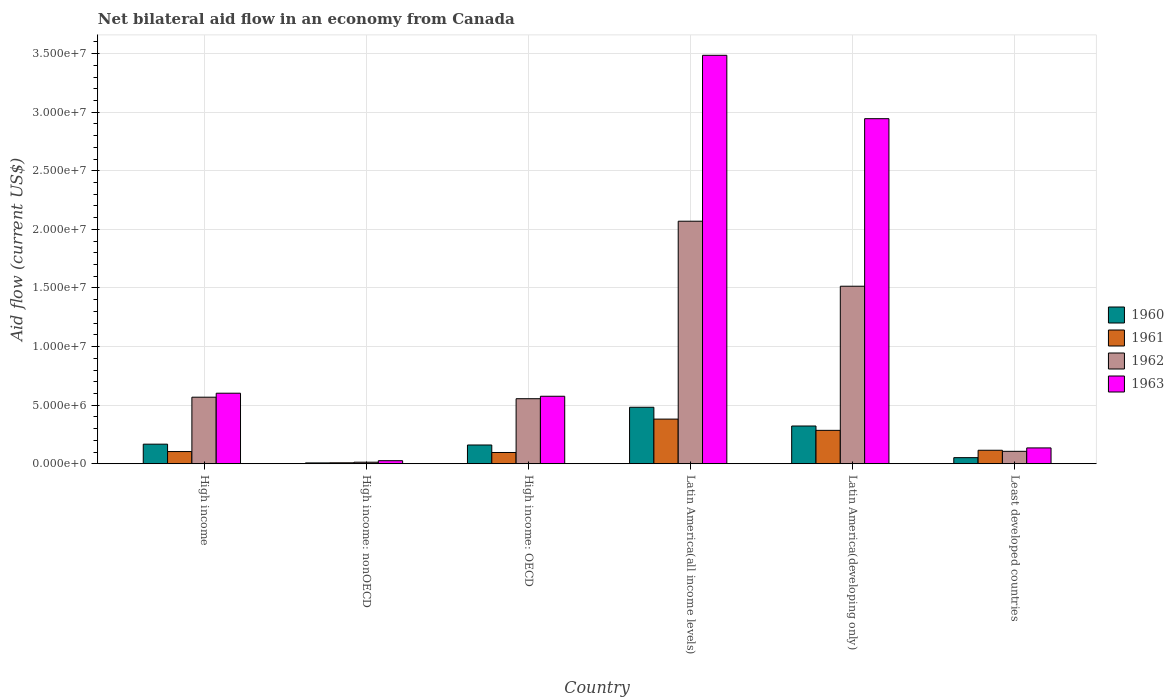How many groups of bars are there?
Keep it short and to the point. 6. Are the number of bars on each tick of the X-axis equal?
Keep it short and to the point. Yes. How many bars are there on the 1st tick from the left?
Provide a short and direct response. 4. How many bars are there on the 5th tick from the right?
Your response must be concise. 4. What is the label of the 2nd group of bars from the left?
Provide a succinct answer. High income: nonOECD. In how many cases, is the number of bars for a given country not equal to the number of legend labels?
Ensure brevity in your answer.  0. What is the net bilateral aid flow in 1961 in Latin America(all income levels)?
Keep it short and to the point. 3.81e+06. Across all countries, what is the maximum net bilateral aid flow in 1963?
Provide a succinct answer. 3.49e+07. Across all countries, what is the minimum net bilateral aid flow in 1960?
Provide a succinct answer. 7.00e+04. In which country was the net bilateral aid flow in 1962 maximum?
Your answer should be compact. Latin America(all income levels). In which country was the net bilateral aid flow in 1963 minimum?
Give a very brief answer. High income: nonOECD. What is the total net bilateral aid flow in 1963 in the graph?
Provide a succinct answer. 7.77e+07. What is the difference between the net bilateral aid flow in 1961 in High income and that in Latin America(developing only)?
Ensure brevity in your answer.  -1.81e+06. What is the difference between the net bilateral aid flow in 1960 in High income: nonOECD and the net bilateral aid flow in 1961 in Least developed countries?
Ensure brevity in your answer.  -1.08e+06. What is the average net bilateral aid flow in 1960 per country?
Offer a terse response. 1.98e+06. What is the difference between the net bilateral aid flow of/in 1962 and net bilateral aid flow of/in 1960 in Latin America(developing only)?
Your answer should be compact. 1.19e+07. In how many countries, is the net bilateral aid flow in 1960 greater than 17000000 US$?
Provide a succinct answer. 0. What is the ratio of the net bilateral aid flow in 1963 in High income: nonOECD to that in Latin America(developing only)?
Your answer should be compact. 0.01. Is the net bilateral aid flow in 1962 in High income: OECD less than that in Latin America(developing only)?
Give a very brief answer. Yes. What is the difference between the highest and the second highest net bilateral aid flow in 1960?
Ensure brevity in your answer.  1.60e+06. What is the difference between the highest and the lowest net bilateral aid flow in 1960?
Your answer should be compact. 4.75e+06. In how many countries, is the net bilateral aid flow in 1962 greater than the average net bilateral aid flow in 1962 taken over all countries?
Make the answer very short. 2. Is the sum of the net bilateral aid flow in 1963 in Latin America(developing only) and Least developed countries greater than the maximum net bilateral aid flow in 1960 across all countries?
Make the answer very short. Yes. Is it the case that in every country, the sum of the net bilateral aid flow in 1960 and net bilateral aid flow in 1963 is greater than the sum of net bilateral aid flow in 1961 and net bilateral aid flow in 1962?
Your answer should be very brief. No. What does the 1st bar from the left in High income: nonOECD represents?
Offer a very short reply. 1960. Is it the case that in every country, the sum of the net bilateral aid flow in 1961 and net bilateral aid flow in 1962 is greater than the net bilateral aid flow in 1963?
Offer a terse response. No. How many bars are there?
Your answer should be very brief. 24. Are all the bars in the graph horizontal?
Give a very brief answer. No. How many countries are there in the graph?
Make the answer very short. 6. How many legend labels are there?
Make the answer very short. 4. How are the legend labels stacked?
Your answer should be very brief. Vertical. What is the title of the graph?
Make the answer very short. Net bilateral aid flow in an economy from Canada. Does "1974" appear as one of the legend labels in the graph?
Provide a short and direct response. No. What is the label or title of the Y-axis?
Provide a short and direct response. Aid flow (current US$). What is the Aid flow (current US$) in 1960 in High income?
Provide a succinct answer. 1.67e+06. What is the Aid flow (current US$) in 1961 in High income?
Ensure brevity in your answer.  1.04e+06. What is the Aid flow (current US$) of 1962 in High income?
Offer a terse response. 5.68e+06. What is the Aid flow (current US$) in 1963 in High income?
Provide a succinct answer. 6.02e+06. What is the Aid flow (current US$) of 1960 in High income: nonOECD?
Offer a terse response. 7.00e+04. What is the Aid flow (current US$) in 1960 in High income: OECD?
Offer a terse response. 1.60e+06. What is the Aid flow (current US$) of 1961 in High income: OECD?
Make the answer very short. 9.60e+05. What is the Aid flow (current US$) of 1962 in High income: OECD?
Your answer should be compact. 5.55e+06. What is the Aid flow (current US$) of 1963 in High income: OECD?
Offer a terse response. 5.76e+06. What is the Aid flow (current US$) in 1960 in Latin America(all income levels)?
Make the answer very short. 4.82e+06. What is the Aid flow (current US$) of 1961 in Latin America(all income levels)?
Ensure brevity in your answer.  3.81e+06. What is the Aid flow (current US$) in 1962 in Latin America(all income levels)?
Ensure brevity in your answer.  2.07e+07. What is the Aid flow (current US$) of 1963 in Latin America(all income levels)?
Keep it short and to the point. 3.49e+07. What is the Aid flow (current US$) of 1960 in Latin America(developing only)?
Your answer should be compact. 3.22e+06. What is the Aid flow (current US$) in 1961 in Latin America(developing only)?
Ensure brevity in your answer.  2.85e+06. What is the Aid flow (current US$) of 1962 in Latin America(developing only)?
Offer a terse response. 1.52e+07. What is the Aid flow (current US$) of 1963 in Latin America(developing only)?
Give a very brief answer. 2.94e+07. What is the Aid flow (current US$) in 1960 in Least developed countries?
Provide a succinct answer. 5.20e+05. What is the Aid flow (current US$) in 1961 in Least developed countries?
Your answer should be compact. 1.15e+06. What is the Aid flow (current US$) in 1962 in Least developed countries?
Give a very brief answer. 1.06e+06. What is the Aid flow (current US$) in 1963 in Least developed countries?
Keep it short and to the point. 1.35e+06. Across all countries, what is the maximum Aid flow (current US$) in 1960?
Your answer should be very brief. 4.82e+06. Across all countries, what is the maximum Aid flow (current US$) in 1961?
Your response must be concise. 3.81e+06. Across all countries, what is the maximum Aid flow (current US$) of 1962?
Offer a terse response. 2.07e+07. Across all countries, what is the maximum Aid flow (current US$) of 1963?
Ensure brevity in your answer.  3.49e+07. Across all countries, what is the minimum Aid flow (current US$) of 1962?
Your answer should be very brief. 1.30e+05. Across all countries, what is the minimum Aid flow (current US$) in 1963?
Your answer should be compact. 2.60e+05. What is the total Aid flow (current US$) of 1960 in the graph?
Your answer should be very brief. 1.19e+07. What is the total Aid flow (current US$) in 1961 in the graph?
Make the answer very short. 9.89e+06. What is the total Aid flow (current US$) of 1962 in the graph?
Keep it short and to the point. 4.83e+07. What is the total Aid flow (current US$) of 1963 in the graph?
Offer a terse response. 7.77e+07. What is the difference between the Aid flow (current US$) of 1960 in High income and that in High income: nonOECD?
Ensure brevity in your answer.  1.60e+06. What is the difference between the Aid flow (current US$) of 1961 in High income and that in High income: nonOECD?
Keep it short and to the point. 9.60e+05. What is the difference between the Aid flow (current US$) of 1962 in High income and that in High income: nonOECD?
Your response must be concise. 5.55e+06. What is the difference between the Aid flow (current US$) in 1963 in High income and that in High income: nonOECD?
Your answer should be compact. 5.76e+06. What is the difference between the Aid flow (current US$) of 1960 in High income and that in High income: OECD?
Keep it short and to the point. 7.00e+04. What is the difference between the Aid flow (current US$) of 1960 in High income and that in Latin America(all income levels)?
Your response must be concise. -3.15e+06. What is the difference between the Aid flow (current US$) in 1961 in High income and that in Latin America(all income levels)?
Your answer should be compact. -2.77e+06. What is the difference between the Aid flow (current US$) of 1962 in High income and that in Latin America(all income levels)?
Your answer should be very brief. -1.50e+07. What is the difference between the Aid flow (current US$) in 1963 in High income and that in Latin America(all income levels)?
Give a very brief answer. -2.88e+07. What is the difference between the Aid flow (current US$) of 1960 in High income and that in Latin America(developing only)?
Offer a very short reply. -1.55e+06. What is the difference between the Aid flow (current US$) in 1961 in High income and that in Latin America(developing only)?
Give a very brief answer. -1.81e+06. What is the difference between the Aid flow (current US$) in 1962 in High income and that in Latin America(developing only)?
Provide a succinct answer. -9.47e+06. What is the difference between the Aid flow (current US$) of 1963 in High income and that in Latin America(developing only)?
Provide a succinct answer. -2.34e+07. What is the difference between the Aid flow (current US$) of 1960 in High income and that in Least developed countries?
Ensure brevity in your answer.  1.15e+06. What is the difference between the Aid flow (current US$) in 1962 in High income and that in Least developed countries?
Your answer should be very brief. 4.62e+06. What is the difference between the Aid flow (current US$) of 1963 in High income and that in Least developed countries?
Your answer should be compact. 4.67e+06. What is the difference between the Aid flow (current US$) in 1960 in High income: nonOECD and that in High income: OECD?
Make the answer very short. -1.53e+06. What is the difference between the Aid flow (current US$) in 1961 in High income: nonOECD and that in High income: OECD?
Your response must be concise. -8.80e+05. What is the difference between the Aid flow (current US$) of 1962 in High income: nonOECD and that in High income: OECD?
Keep it short and to the point. -5.42e+06. What is the difference between the Aid flow (current US$) in 1963 in High income: nonOECD and that in High income: OECD?
Keep it short and to the point. -5.50e+06. What is the difference between the Aid flow (current US$) in 1960 in High income: nonOECD and that in Latin America(all income levels)?
Keep it short and to the point. -4.75e+06. What is the difference between the Aid flow (current US$) in 1961 in High income: nonOECD and that in Latin America(all income levels)?
Ensure brevity in your answer.  -3.73e+06. What is the difference between the Aid flow (current US$) in 1962 in High income: nonOECD and that in Latin America(all income levels)?
Keep it short and to the point. -2.06e+07. What is the difference between the Aid flow (current US$) of 1963 in High income: nonOECD and that in Latin America(all income levels)?
Your answer should be very brief. -3.46e+07. What is the difference between the Aid flow (current US$) of 1960 in High income: nonOECD and that in Latin America(developing only)?
Your answer should be very brief. -3.15e+06. What is the difference between the Aid flow (current US$) of 1961 in High income: nonOECD and that in Latin America(developing only)?
Your answer should be very brief. -2.77e+06. What is the difference between the Aid flow (current US$) in 1962 in High income: nonOECD and that in Latin America(developing only)?
Give a very brief answer. -1.50e+07. What is the difference between the Aid flow (current US$) in 1963 in High income: nonOECD and that in Latin America(developing only)?
Keep it short and to the point. -2.92e+07. What is the difference between the Aid flow (current US$) in 1960 in High income: nonOECD and that in Least developed countries?
Your answer should be very brief. -4.50e+05. What is the difference between the Aid flow (current US$) of 1961 in High income: nonOECD and that in Least developed countries?
Your response must be concise. -1.07e+06. What is the difference between the Aid flow (current US$) of 1962 in High income: nonOECD and that in Least developed countries?
Make the answer very short. -9.30e+05. What is the difference between the Aid flow (current US$) of 1963 in High income: nonOECD and that in Least developed countries?
Your response must be concise. -1.09e+06. What is the difference between the Aid flow (current US$) in 1960 in High income: OECD and that in Latin America(all income levels)?
Your answer should be compact. -3.22e+06. What is the difference between the Aid flow (current US$) in 1961 in High income: OECD and that in Latin America(all income levels)?
Offer a very short reply. -2.85e+06. What is the difference between the Aid flow (current US$) in 1962 in High income: OECD and that in Latin America(all income levels)?
Give a very brief answer. -1.52e+07. What is the difference between the Aid flow (current US$) in 1963 in High income: OECD and that in Latin America(all income levels)?
Offer a terse response. -2.91e+07. What is the difference between the Aid flow (current US$) in 1960 in High income: OECD and that in Latin America(developing only)?
Your response must be concise. -1.62e+06. What is the difference between the Aid flow (current US$) in 1961 in High income: OECD and that in Latin America(developing only)?
Offer a very short reply. -1.89e+06. What is the difference between the Aid flow (current US$) of 1962 in High income: OECD and that in Latin America(developing only)?
Offer a terse response. -9.60e+06. What is the difference between the Aid flow (current US$) in 1963 in High income: OECD and that in Latin America(developing only)?
Provide a succinct answer. -2.37e+07. What is the difference between the Aid flow (current US$) in 1960 in High income: OECD and that in Least developed countries?
Your answer should be very brief. 1.08e+06. What is the difference between the Aid flow (current US$) in 1961 in High income: OECD and that in Least developed countries?
Make the answer very short. -1.90e+05. What is the difference between the Aid flow (current US$) in 1962 in High income: OECD and that in Least developed countries?
Offer a very short reply. 4.49e+06. What is the difference between the Aid flow (current US$) of 1963 in High income: OECD and that in Least developed countries?
Offer a terse response. 4.41e+06. What is the difference between the Aid flow (current US$) in 1960 in Latin America(all income levels) and that in Latin America(developing only)?
Your answer should be compact. 1.60e+06. What is the difference between the Aid flow (current US$) of 1961 in Latin America(all income levels) and that in Latin America(developing only)?
Ensure brevity in your answer.  9.60e+05. What is the difference between the Aid flow (current US$) of 1962 in Latin America(all income levels) and that in Latin America(developing only)?
Your response must be concise. 5.55e+06. What is the difference between the Aid flow (current US$) of 1963 in Latin America(all income levels) and that in Latin America(developing only)?
Provide a succinct answer. 5.41e+06. What is the difference between the Aid flow (current US$) of 1960 in Latin America(all income levels) and that in Least developed countries?
Your answer should be compact. 4.30e+06. What is the difference between the Aid flow (current US$) of 1961 in Latin America(all income levels) and that in Least developed countries?
Offer a very short reply. 2.66e+06. What is the difference between the Aid flow (current US$) of 1962 in Latin America(all income levels) and that in Least developed countries?
Provide a succinct answer. 1.96e+07. What is the difference between the Aid flow (current US$) in 1963 in Latin America(all income levels) and that in Least developed countries?
Ensure brevity in your answer.  3.35e+07. What is the difference between the Aid flow (current US$) in 1960 in Latin America(developing only) and that in Least developed countries?
Your answer should be compact. 2.70e+06. What is the difference between the Aid flow (current US$) of 1961 in Latin America(developing only) and that in Least developed countries?
Provide a succinct answer. 1.70e+06. What is the difference between the Aid flow (current US$) of 1962 in Latin America(developing only) and that in Least developed countries?
Your answer should be very brief. 1.41e+07. What is the difference between the Aid flow (current US$) in 1963 in Latin America(developing only) and that in Least developed countries?
Provide a short and direct response. 2.81e+07. What is the difference between the Aid flow (current US$) in 1960 in High income and the Aid flow (current US$) in 1961 in High income: nonOECD?
Keep it short and to the point. 1.59e+06. What is the difference between the Aid flow (current US$) of 1960 in High income and the Aid flow (current US$) of 1962 in High income: nonOECD?
Give a very brief answer. 1.54e+06. What is the difference between the Aid flow (current US$) in 1960 in High income and the Aid flow (current US$) in 1963 in High income: nonOECD?
Give a very brief answer. 1.41e+06. What is the difference between the Aid flow (current US$) in 1961 in High income and the Aid flow (current US$) in 1962 in High income: nonOECD?
Make the answer very short. 9.10e+05. What is the difference between the Aid flow (current US$) in 1961 in High income and the Aid flow (current US$) in 1963 in High income: nonOECD?
Provide a succinct answer. 7.80e+05. What is the difference between the Aid flow (current US$) of 1962 in High income and the Aid flow (current US$) of 1963 in High income: nonOECD?
Provide a short and direct response. 5.42e+06. What is the difference between the Aid flow (current US$) of 1960 in High income and the Aid flow (current US$) of 1961 in High income: OECD?
Your answer should be compact. 7.10e+05. What is the difference between the Aid flow (current US$) in 1960 in High income and the Aid flow (current US$) in 1962 in High income: OECD?
Provide a succinct answer. -3.88e+06. What is the difference between the Aid flow (current US$) in 1960 in High income and the Aid flow (current US$) in 1963 in High income: OECD?
Offer a very short reply. -4.09e+06. What is the difference between the Aid flow (current US$) in 1961 in High income and the Aid flow (current US$) in 1962 in High income: OECD?
Offer a terse response. -4.51e+06. What is the difference between the Aid flow (current US$) of 1961 in High income and the Aid flow (current US$) of 1963 in High income: OECD?
Give a very brief answer. -4.72e+06. What is the difference between the Aid flow (current US$) in 1960 in High income and the Aid flow (current US$) in 1961 in Latin America(all income levels)?
Keep it short and to the point. -2.14e+06. What is the difference between the Aid flow (current US$) of 1960 in High income and the Aid flow (current US$) of 1962 in Latin America(all income levels)?
Provide a succinct answer. -1.90e+07. What is the difference between the Aid flow (current US$) in 1960 in High income and the Aid flow (current US$) in 1963 in Latin America(all income levels)?
Provide a short and direct response. -3.32e+07. What is the difference between the Aid flow (current US$) of 1961 in High income and the Aid flow (current US$) of 1962 in Latin America(all income levels)?
Keep it short and to the point. -1.97e+07. What is the difference between the Aid flow (current US$) in 1961 in High income and the Aid flow (current US$) in 1963 in Latin America(all income levels)?
Provide a succinct answer. -3.38e+07. What is the difference between the Aid flow (current US$) of 1962 in High income and the Aid flow (current US$) of 1963 in Latin America(all income levels)?
Provide a short and direct response. -2.92e+07. What is the difference between the Aid flow (current US$) in 1960 in High income and the Aid flow (current US$) in 1961 in Latin America(developing only)?
Your response must be concise. -1.18e+06. What is the difference between the Aid flow (current US$) in 1960 in High income and the Aid flow (current US$) in 1962 in Latin America(developing only)?
Offer a very short reply. -1.35e+07. What is the difference between the Aid flow (current US$) in 1960 in High income and the Aid flow (current US$) in 1963 in Latin America(developing only)?
Make the answer very short. -2.78e+07. What is the difference between the Aid flow (current US$) of 1961 in High income and the Aid flow (current US$) of 1962 in Latin America(developing only)?
Make the answer very short. -1.41e+07. What is the difference between the Aid flow (current US$) in 1961 in High income and the Aid flow (current US$) in 1963 in Latin America(developing only)?
Your answer should be compact. -2.84e+07. What is the difference between the Aid flow (current US$) in 1962 in High income and the Aid flow (current US$) in 1963 in Latin America(developing only)?
Your answer should be very brief. -2.38e+07. What is the difference between the Aid flow (current US$) in 1960 in High income and the Aid flow (current US$) in 1961 in Least developed countries?
Your response must be concise. 5.20e+05. What is the difference between the Aid flow (current US$) of 1960 in High income and the Aid flow (current US$) of 1963 in Least developed countries?
Provide a short and direct response. 3.20e+05. What is the difference between the Aid flow (current US$) of 1961 in High income and the Aid flow (current US$) of 1962 in Least developed countries?
Your answer should be very brief. -2.00e+04. What is the difference between the Aid flow (current US$) in 1961 in High income and the Aid flow (current US$) in 1963 in Least developed countries?
Your response must be concise. -3.10e+05. What is the difference between the Aid flow (current US$) in 1962 in High income and the Aid flow (current US$) in 1963 in Least developed countries?
Your response must be concise. 4.33e+06. What is the difference between the Aid flow (current US$) of 1960 in High income: nonOECD and the Aid flow (current US$) of 1961 in High income: OECD?
Ensure brevity in your answer.  -8.90e+05. What is the difference between the Aid flow (current US$) of 1960 in High income: nonOECD and the Aid flow (current US$) of 1962 in High income: OECD?
Keep it short and to the point. -5.48e+06. What is the difference between the Aid flow (current US$) of 1960 in High income: nonOECD and the Aid flow (current US$) of 1963 in High income: OECD?
Keep it short and to the point. -5.69e+06. What is the difference between the Aid flow (current US$) in 1961 in High income: nonOECD and the Aid flow (current US$) in 1962 in High income: OECD?
Make the answer very short. -5.47e+06. What is the difference between the Aid flow (current US$) in 1961 in High income: nonOECD and the Aid flow (current US$) in 1963 in High income: OECD?
Give a very brief answer. -5.68e+06. What is the difference between the Aid flow (current US$) in 1962 in High income: nonOECD and the Aid flow (current US$) in 1963 in High income: OECD?
Provide a succinct answer. -5.63e+06. What is the difference between the Aid flow (current US$) in 1960 in High income: nonOECD and the Aid flow (current US$) in 1961 in Latin America(all income levels)?
Make the answer very short. -3.74e+06. What is the difference between the Aid flow (current US$) of 1960 in High income: nonOECD and the Aid flow (current US$) of 1962 in Latin America(all income levels)?
Provide a short and direct response. -2.06e+07. What is the difference between the Aid flow (current US$) in 1960 in High income: nonOECD and the Aid flow (current US$) in 1963 in Latin America(all income levels)?
Ensure brevity in your answer.  -3.48e+07. What is the difference between the Aid flow (current US$) of 1961 in High income: nonOECD and the Aid flow (current US$) of 1962 in Latin America(all income levels)?
Ensure brevity in your answer.  -2.06e+07. What is the difference between the Aid flow (current US$) of 1961 in High income: nonOECD and the Aid flow (current US$) of 1963 in Latin America(all income levels)?
Make the answer very short. -3.48e+07. What is the difference between the Aid flow (current US$) of 1962 in High income: nonOECD and the Aid flow (current US$) of 1963 in Latin America(all income levels)?
Provide a short and direct response. -3.47e+07. What is the difference between the Aid flow (current US$) of 1960 in High income: nonOECD and the Aid flow (current US$) of 1961 in Latin America(developing only)?
Make the answer very short. -2.78e+06. What is the difference between the Aid flow (current US$) in 1960 in High income: nonOECD and the Aid flow (current US$) in 1962 in Latin America(developing only)?
Your answer should be very brief. -1.51e+07. What is the difference between the Aid flow (current US$) in 1960 in High income: nonOECD and the Aid flow (current US$) in 1963 in Latin America(developing only)?
Keep it short and to the point. -2.94e+07. What is the difference between the Aid flow (current US$) of 1961 in High income: nonOECD and the Aid flow (current US$) of 1962 in Latin America(developing only)?
Make the answer very short. -1.51e+07. What is the difference between the Aid flow (current US$) of 1961 in High income: nonOECD and the Aid flow (current US$) of 1963 in Latin America(developing only)?
Offer a very short reply. -2.94e+07. What is the difference between the Aid flow (current US$) of 1962 in High income: nonOECD and the Aid flow (current US$) of 1963 in Latin America(developing only)?
Your response must be concise. -2.93e+07. What is the difference between the Aid flow (current US$) in 1960 in High income: nonOECD and the Aid flow (current US$) in 1961 in Least developed countries?
Provide a short and direct response. -1.08e+06. What is the difference between the Aid flow (current US$) in 1960 in High income: nonOECD and the Aid flow (current US$) in 1962 in Least developed countries?
Your response must be concise. -9.90e+05. What is the difference between the Aid flow (current US$) in 1960 in High income: nonOECD and the Aid flow (current US$) in 1963 in Least developed countries?
Give a very brief answer. -1.28e+06. What is the difference between the Aid flow (current US$) of 1961 in High income: nonOECD and the Aid flow (current US$) of 1962 in Least developed countries?
Provide a succinct answer. -9.80e+05. What is the difference between the Aid flow (current US$) of 1961 in High income: nonOECD and the Aid flow (current US$) of 1963 in Least developed countries?
Provide a succinct answer. -1.27e+06. What is the difference between the Aid flow (current US$) of 1962 in High income: nonOECD and the Aid flow (current US$) of 1963 in Least developed countries?
Make the answer very short. -1.22e+06. What is the difference between the Aid flow (current US$) of 1960 in High income: OECD and the Aid flow (current US$) of 1961 in Latin America(all income levels)?
Offer a terse response. -2.21e+06. What is the difference between the Aid flow (current US$) of 1960 in High income: OECD and the Aid flow (current US$) of 1962 in Latin America(all income levels)?
Provide a succinct answer. -1.91e+07. What is the difference between the Aid flow (current US$) in 1960 in High income: OECD and the Aid flow (current US$) in 1963 in Latin America(all income levels)?
Offer a very short reply. -3.33e+07. What is the difference between the Aid flow (current US$) in 1961 in High income: OECD and the Aid flow (current US$) in 1962 in Latin America(all income levels)?
Keep it short and to the point. -1.97e+07. What is the difference between the Aid flow (current US$) in 1961 in High income: OECD and the Aid flow (current US$) in 1963 in Latin America(all income levels)?
Your answer should be very brief. -3.39e+07. What is the difference between the Aid flow (current US$) of 1962 in High income: OECD and the Aid flow (current US$) of 1963 in Latin America(all income levels)?
Your answer should be very brief. -2.93e+07. What is the difference between the Aid flow (current US$) in 1960 in High income: OECD and the Aid flow (current US$) in 1961 in Latin America(developing only)?
Your response must be concise. -1.25e+06. What is the difference between the Aid flow (current US$) in 1960 in High income: OECD and the Aid flow (current US$) in 1962 in Latin America(developing only)?
Provide a succinct answer. -1.36e+07. What is the difference between the Aid flow (current US$) of 1960 in High income: OECD and the Aid flow (current US$) of 1963 in Latin America(developing only)?
Your answer should be very brief. -2.78e+07. What is the difference between the Aid flow (current US$) of 1961 in High income: OECD and the Aid flow (current US$) of 1962 in Latin America(developing only)?
Provide a short and direct response. -1.42e+07. What is the difference between the Aid flow (current US$) of 1961 in High income: OECD and the Aid flow (current US$) of 1963 in Latin America(developing only)?
Offer a terse response. -2.85e+07. What is the difference between the Aid flow (current US$) of 1962 in High income: OECD and the Aid flow (current US$) of 1963 in Latin America(developing only)?
Keep it short and to the point. -2.39e+07. What is the difference between the Aid flow (current US$) of 1960 in High income: OECD and the Aid flow (current US$) of 1962 in Least developed countries?
Make the answer very short. 5.40e+05. What is the difference between the Aid flow (current US$) in 1960 in High income: OECD and the Aid flow (current US$) in 1963 in Least developed countries?
Provide a succinct answer. 2.50e+05. What is the difference between the Aid flow (current US$) of 1961 in High income: OECD and the Aid flow (current US$) of 1962 in Least developed countries?
Provide a succinct answer. -1.00e+05. What is the difference between the Aid flow (current US$) of 1961 in High income: OECD and the Aid flow (current US$) of 1963 in Least developed countries?
Make the answer very short. -3.90e+05. What is the difference between the Aid flow (current US$) in 1962 in High income: OECD and the Aid flow (current US$) in 1963 in Least developed countries?
Provide a short and direct response. 4.20e+06. What is the difference between the Aid flow (current US$) in 1960 in Latin America(all income levels) and the Aid flow (current US$) in 1961 in Latin America(developing only)?
Your answer should be very brief. 1.97e+06. What is the difference between the Aid flow (current US$) of 1960 in Latin America(all income levels) and the Aid flow (current US$) of 1962 in Latin America(developing only)?
Provide a succinct answer. -1.03e+07. What is the difference between the Aid flow (current US$) of 1960 in Latin America(all income levels) and the Aid flow (current US$) of 1963 in Latin America(developing only)?
Ensure brevity in your answer.  -2.46e+07. What is the difference between the Aid flow (current US$) in 1961 in Latin America(all income levels) and the Aid flow (current US$) in 1962 in Latin America(developing only)?
Give a very brief answer. -1.13e+07. What is the difference between the Aid flow (current US$) of 1961 in Latin America(all income levels) and the Aid flow (current US$) of 1963 in Latin America(developing only)?
Keep it short and to the point. -2.56e+07. What is the difference between the Aid flow (current US$) in 1962 in Latin America(all income levels) and the Aid flow (current US$) in 1963 in Latin America(developing only)?
Your answer should be very brief. -8.75e+06. What is the difference between the Aid flow (current US$) in 1960 in Latin America(all income levels) and the Aid flow (current US$) in 1961 in Least developed countries?
Your response must be concise. 3.67e+06. What is the difference between the Aid flow (current US$) of 1960 in Latin America(all income levels) and the Aid flow (current US$) of 1962 in Least developed countries?
Provide a succinct answer. 3.76e+06. What is the difference between the Aid flow (current US$) of 1960 in Latin America(all income levels) and the Aid flow (current US$) of 1963 in Least developed countries?
Your answer should be compact. 3.47e+06. What is the difference between the Aid flow (current US$) in 1961 in Latin America(all income levels) and the Aid flow (current US$) in 1962 in Least developed countries?
Make the answer very short. 2.75e+06. What is the difference between the Aid flow (current US$) in 1961 in Latin America(all income levels) and the Aid flow (current US$) in 1963 in Least developed countries?
Ensure brevity in your answer.  2.46e+06. What is the difference between the Aid flow (current US$) in 1962 in Latin America(all income levels) and the Aid flow (current US$) in 1963 in Least developed countries?
Make the answer very short. 1.94e+07. What is the difference between the Aid flow (current US$) in 1960 in Latin America(developing only) and the Aid flow (current US$) in 1961 in Least developed countries?
Your response must be concise. 2.07e+06. What is the difference between the Aid flow (current US$) of 1960 in Latin America(developing only) and the Aid flow (current US$) of 1962 in Least developed countries?
Offer a very short reply. 2.16e+06. What is the difference between the Aid flow (current US$) of 1960 in Latin America(developing only) and the Aid flow (current US$) of 1963 in Least developed countries?
Provide a succinct answer. 1.87e+06. What is the difference between the Aid flow (current US$) in 1961 in Latin America(developing only) and the Aid flow (current US$) in 1962 in Least developed countries?
Your answer should be compact. 1.79e+06. What is the difference between the Aid flow (current US$) of 1961 in Latin America(developing only) and the Aid flow (current US$) of 1963 in Least developed countries?
Offer a terse response. 1.50e+06. What is the difference between the Aid flow (current US$) of 1962 in Latin America(developing only) and the Aid flow (current US$) of 1963 in Least developed countries?
Provide a succinct answer. 1.38e+07. What is the average Aid flow (current US$) in 1960 per country?
Give a very brief answer. 1.98e+06. What is the average Aid flow (current US$) of 1961 per country?
Your response must be concise. 1.65e+06. What is the average Aid flow (current US$) in 1962 per country?
Keep it short and to the point. 8.04e+06. What is the average Aid flow (current US$) of 1963 per country?
Offer a very short reply. 1.30e+07. What is the difference between the Aid flow (current US$) in 1960 and Aid flow (current US$) in 1961 in High income?
Ensure brevity in your answer.  6.30e+05. What is the difference between the Aid flow (current US$) in 1960 and Aid flow (current US$) in 1962 in High income?
Provide a succinct answer. -4.01e+06. What is the difference between the Aid flow (current US$) of 1960 and Aid flow (current US$) of 1963 in High income?
Your response must be concise. -4.35e+06. What is the difference between the Aid flow (current US$) in 1961 and Aid flow (current US$) in 1962 in High income?
Make the answer very short. -4.64e+06. What is the difference between the Aid flow (current US$) in 1961 and Aid flow (current US$) in 1963 in High income?
Keep it short and to the point. -4.98e+06. What is the difference between the Aid flow (current US$) of 1960 and Aid flow (current US$) of 1961 in High income: nonOECD?
Provide a succinct answer. -10000. What is the difference between the Aid flow (current US$) of 1960 and Aid flow (current US$) of 1963 in High income: nonOECD?
Offer a terse response. -1.90e+05. What is the difference between the Aid flow (current US$) of 1961 and Aid flow (current US$) of 1962 in High income: nonOECD?
Offer a terse response. -5.00e+04. What is the difference between the Aid flow (current US$) of 1961 and Aid flow (current US$) of 1963 in High income: nonOECD?
Offer a very short reply. -1.80e+05. What is the difference between the Aid flow (current US$) of 1960 and Aid flow (current US$) of 1961 in High income: OECD?
Your response must be concise. 6.40e+05. What is the difference between the Aid flow (current US$) of 1960 and Aid flow (current US$) of 1962 in High income: OECD?
Offer a very short reply. -3.95e+06. What is the difference between the Aid flow (current US$) of 1960 and Aid flow (current US$) of 1963 in High income: OECD?
Give a very brief answer. -4.16e+06. What is the difference between the Aid flow (current US$) in 1961 and Aid flow (current US$) in 1962 in High income: OECD?
Make the answer very short. -4.59e+06. What is the difference between the Aid flow (current US$) of 1961 and Aid flow (current US$) of 1963 in High income: OECD?
Provide a succinct answer. -4.80e+06. What is the difference between the Aid flow (current US$) of 1962 and Aid flow (current US$) of 1963 in High income: OECD?
Give a very brief answer. -2.10e+05. What is the difference between the Aid flow (current US$) of 1960 and Aid flow (current US$) of 1961 in Latin America(all income levels)?
Provide a succinct answer. 1.01e+06. What is the difference between the Aid flow (current US$) of 1960 and Aid flow (current US$) of 1962 in Latin America(all income levels)?
Offer a very short reply. -1.59e+07. What is the difference between the Aid flow (current US$) of 1960 and Aid flow (current US$) of 1963 in Latin America(all income levels)?
Provide a succinct answer. -3.00e+07. What is the difference between the Aid flow (current US$) in 1961 and Aid flow (current US$) in 1962 in Latin America(all income levels)?
Your answer should be very brief. -1.69e+07. What is the difference between the Aid flow (current US$) in 1961 and Aid flow (current US$) in 1963 in Latin America(all income levels)?
Your response must be concise. -3.10e+07. What is the difference between the Aid flow (current US$) of 1962 and Aid flow (current US$) of 1963 in Latin America(all income levels)?
Keep it short and to the point. -1.42e+07. What is the difference between the Aid flow (current US$) of 1960 and Aid flow (current US$) of 1962 in Latin America(developing only)?
Your answer should be compact. -1.19e+07. What is the difference between the Aid flow (current US$) of 1960 and Aid flow (current US$) of 1963 in Latin America(developing only)?
Provide a succinct answer. -2.62e+07. What is the difference between the Aid flow (current US$) in 1961 and Aid flow (current US$) in 1962 in Latin America(developing only)?
Offer a terse response. -1.23e+07. What is the difference between the Aid flow (current US$) in 1961 and Aid flow (current US$) in 1963 in Latin America(developing only)?
Provide a short and direct response. -2.66e+07. What is the difference between the Aid flow (current US$) in 1962 and Aid flow (current US$) in 1963 in Latin America(developing only)?
Provide a succinct answer. -1.43e+07. What is the difference between the Aid flow (current US$) of 1960 and Aid flow (current US$) of 1961 in Least developed countries?
Your answer should be very brief. -6.30e+05. What is the difference between the Aid flow (current US$) in 1960 and Aid flow (current US$) in 1962 in Least developed countries?
Keep it short and to the point. -5.40e+05. What is the difference between the Aid flow (current US$) of 1960 and Aid flow (current US$) of 1963 in Least developed countries?
Your answer should be very brief. -8.30e+05. What is the difference between the Aid flow (current US$) in 1961 and Aid flow (current US$) in 1962 in Least developed countries?
Your answer should be very brief. 9.00e+04. What is the ratio of the Aid flow (current US$) in 1960 in High income to that in High income: nonOECD?
Make the answer very short. 23.86. What is the ratio of the Aid flow (current US$) in 1962 in High income to that in High income: nonOECD?
Your answer should be compact. 43.69. What is the ratio of the Aid flow (current US$) in 1963 in High income to that in High income: nonOECD?
Make the answer very short. 23.15. What is the ratio of the Aid flow (current US$) in 1960 in High income to that in High income: OECD?
Your answer should be very brief. 1.04. What is the ratio of the Aid flow (current US$) of 1961 in High income to that in High income: OECD?
Ensure brevity in your answer.  1.08. What is the ratio of the Aid flow (current US$) of 1962 in High income to that in High income: OECD?
Give a very brief answer. 1.02. What is the ratio of the Aid flow (current US$) in 1963 in High income to that in High income: OECD?
Your answer should be very brief. 1.05. What is the ratio of the Aid flow (current US$) in 1960 in High income to that in Latin America(all income levels)?
Give a very brief answer. 0.35. What is the ratio of the Aid flow (current US$) in 1961 in High income to that in Latin America(all income levels)?
Offer a terse response. 0.27. What is the ratio of the Aid flow (current US$) in 1962 in High income to that in Latin America(all income levels)?
Give a very brief answer. 0.27. What is the ratio of the Aid flow (current US$) in 1963 in High income to that in Latin America(all income levels)?
Offer a very short reply. 0.17. What is the ratio of the Aid flow (current US$) of 1960 in High income to that in Latin America(developing only)?
Ensure brevity in your answer.  0.52. What is the ratio of the Aid flow (current US$) in 1961 in High income to that in Latin America(developing only)?
Offer a terse response. 0.36. What is the ratio of the Aid flow (current US$) in 1962 in High income to that in Latin America(developing only)?
Ensure brevity in your answer.  0.37. What is the ratio of the Aid flow (current US$) in 1963 in High income to that in Latin America(developing only)?
Your answer should be very brief. 0.2. What is the ratio of the Aid flow (current US$) in 1960 in High income to that in Least developed countries?
Keep it short and to the point. 3.21. What is the ratio of the Aid flow (current US$) in 1961 in High income to that in Least developed countries?
Offer a terse response. 0.9. What is the ratio of the Aid flow (current US$) of 1962 in High income to that in Least developed countries?
Make the answer very short. 5.36. What is the ratio of the Aid flow (current US$) of 1963 in High income to that in Least developed countries?
Your answer should be compact. 4.46. What is the ratio of the Aid flow (current US$) of 1960 in High income: nonOECD to that in High income: OECD?
Make the answer very short. 0.04. What is the ratio of the Aid flow (current US$) in 1961 in High income: nonOECD to that in High income: OECD?
Your response must be concise. 0.08. What is the ratio of the Aid flow (current US$) in 1962 in High income: nonOECD to that in High income: OECD?
Provide a succinct answer. 0.02. What is the ratio of the Aid flow (current US$) of 1963 in High income: nonOECD to that in High income: OECD?
Provide a succinct answer. 0.05. What is the ratio of the Aid flow (current US$) in 1960 in High income: nonOECD to that in Latin America(all income levels)?
Offer a very short reply. 0.01. What is the ratio of the Aid flow (current US$) of 1961 in High income: nonOECD to that in Latin America(all income levels)?
Ensure brevity in your answer.  0.02. What is the ratio of the Aid flow (current US$) of 1962 in High income: nonOECD to that in Latin America(all income levels)?
Provide a short and direct response. 0.01. What is the ratio of the Aid flow (current US$) of 1963 in High income: nonOECD to that in Latin America(all income levels)?
Make the answer very short. 0.01. What is the ratio of the Aid flow (current US$) of 1960 in High income: nonOECD to that in Latin America(developing only)?
Offer a terse response. 0.02. What is the ratio of the Aid flow (current US$) of 1961 in High income: nonOECD to that in Latin America(developing only)?
Provide a succinct answer. 0.03. What is the ratio of the Aid flow (current US$) of 1962 in High income: nonOECD to that in Latin America(developing only)?
Ensure brevity in your answer.  0.01. What is the ratio of the Aid flow (current US$) of 1963 in High income: nonOECD to that in Latin America(developing only)?
Provide a succinct answer. 0.01. What is the ratio of the Aid flow (current US$) in 1960 in High income: nonOECD to that in Least developed countries?
Offer a terse response. 0.13. What is the ratio of the Aid flow (current US$) of 1961 in High income: nonOECD to that in Least developed countries?
Ensure brevity in your answer.  0.07. What is the ratio of the Aid flow (current US$) in 1962 in High income: nonOECD to that in Least developed countries?
Make the answer very short. 0.12. What is the ratio of the Aid flow (current US$) in 1963 in High income: nonOECD to that in Least developed countries?
Keep it short and to the point. 0.19. What is the ratio of the Aid flow (current US$) of 1960 in High income: OECD to that in Latin America(all income levels)?
Offer a very short reply. 0.33. What is the ratio of the Aid flow (current US$) of 1961 in High income: OECD to that in Latin America(all income levels)?
Your response must be concise. 0.25. What is the ratio of the Aid flow (current US$) in 1962 in High income: OECD to that in Latin America(all income levels)?
Provide a short and direct response. 0.27. What is the ratio of the Aid flow (current US$) in 1963 in High income: OECD to that in Latin America(all income levels)?
Make the answer very short. 0.17. What is the ratio of the Aid flow (current US$) of 1960 in High income: OECD to that in Latin America(developing only)?
Offer a very short reply. 0.5. What is the ratio of the Aid flow (current US$) in 1961 in High income: OECD to that in Latin America(developing only)?
Your response must be concise. 0.34. What is the ratio of the Aid flow (current US$) of 1962 in High income: OECD to that in Latin America(developing only)?
Ensure brevity in your answer.  0.37. What is the ratio of the Aid flow (current US$) in 1963 in High income: OECD to that in Latin America(developing only)?
Give a very brief answer. 0.2. What is the ratio of the Aid flow (current US$) of 1960 in High income: OECD to that in Least developed countries?
Provide a succinct answer. 3.08. What is the ratio of the Aid flow (current US$) in 1961 in High income: OECD to that in Least developed countries?
Keep it short and to the point. 0.83. What is the ratio of the Aid flow (current US$) in 1962 in High income: OECD to that in Least developed countries?
Keep it short and to the point. 5.24. What is the ratio of the Aid flow (current US$) of 1963 in High income: OECD to that in Least developed countries?
Offer a very short reply. 4.27. What is the ratio of the Aid flow (current US$) of 1960 in Latin America(all income levels) to that in Latin America(developing only)?
Ensure brevity in your answer.  1.5. What is the ratio of the Aid flow (current US$) of 1961 in Latin America(all income levels) to that in Latin America(developing only)?
Provide a short and direct response. 1.34. What is the ratio of the Aid flow (current US$) of 1962 in Latin America(all income levels) to that in Latin America(developing only)?
Your answer should be very brief. 1.37. What is the ratio of the Aid flow (current US$) in 1963 in Latin America(all income levels) to that in Latin America(developing only)?
Ensure brevity in your answer.  1.18. What is the ratio of the Aid flow (current US$) of 1960 in Latin America(all income levels) to that in Least developed countries?
Provide a short and direct response. 9.27. What is the ratio of the Aid flow (current US$) in 1961 in Latin America(all income levels) to that in Least developed countries?
Make the answer very short. 3.31. What is the ratio of the Aid flow (current US$) in 1962 in Latin America(all income levels) to that in Least developed countries?
Your answer should be very brief. 19.53. What is the ratio of the Aid flow (current US$) in 1963 in Latin America(all income levels) to that in Least developed countries?
Your response must be concise. 25.82. What is the ratio of the Aid flow (current US$) in 1960 in Latin America(developing only) to that in Least developed countries?
Provide a short and direct response. 6.19. What is the ratio of the Aid flow (current US$) of 1961 in Latin America(developing only) to that in Least developed countries?
Keep it short and to the point. 2.48. What is the ratio of the Aid flow (current US$) of 1962 in Latin America(developing only) to that in Least developed countries?
Make the answer very short. 14.29. What is the ratio of the Aid flow (current US$) in 1963 in Latin America(developing only) to that in Least developed countries?
Offer a very short reply. 21.81. What is the difference between the highest and the second highest Aid flow (current US$) of 1960?
Make the answer very short. 1.60e+06. What is the difference between the highest and the second highest Aid flow (current US$) of 1961?
Ensure brevity in your answer.  9.60e+05. What is the difference between the highest and the second highest Aid flow (current US$) in 1962?
Make the answer very short. 5.55e+06. What is the difference between the highest and the second highest Aid flow (current US$) of 1963?
Offer a terse response. 5.41e+06. What is the difference between the highest and the lowest Aid flow (current US$) of 1960?
Provide a succinct answer. 4.75e+06. What is the difference between the highest and the lowest Aid flow (current US$) in 1961?
Your answer should be compact. 3.73e+06. What is the difference between the highest and the lowest Aid flow (current US$) of 1962?
Offer a very short reply. 2.06e+07. What is the difference between the highest and the lowest Aid flow (current US$) of 1963?
Your response must be concise. 3.46e+07. 